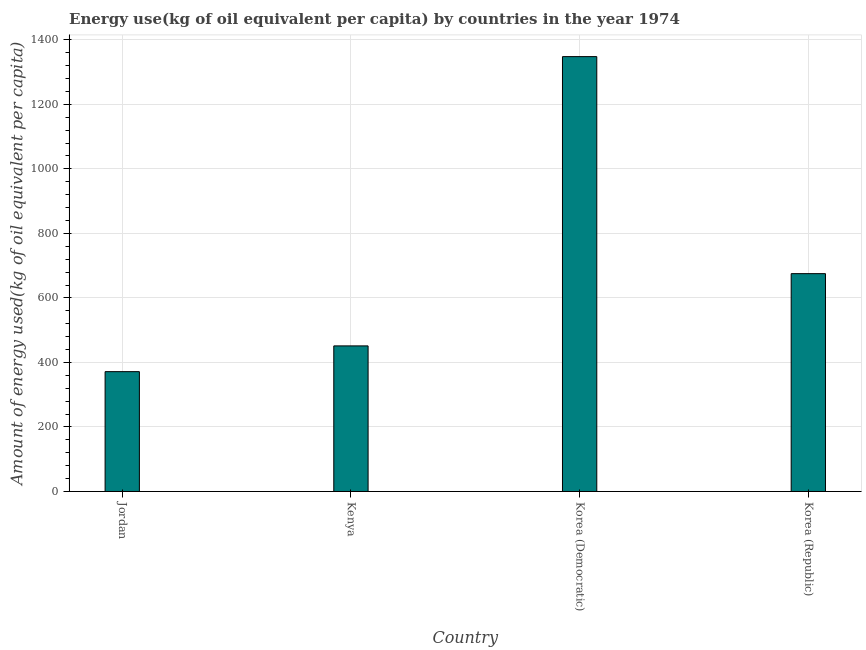Does the graph contain grids?
Offer a terse response. Yes. What is the title of the graph?
Provide a short and direct response. Energy use(kg of oil equivalent per capita) by countries in the year 1974. What is the label or title of the X-axis?
Make the answer very short. Country. What is the label or title of the Y-axis?
Your answer should be compact. Amount of energy used(kg of oil equivalent per capita). What is the amount of energy used in Korea (Democratic)?
Offer a very short reply. 1348.04. Across all countries, what is the maximum amount of energy used?
Provide a succinct answer. 1348.04. Across all countries, what is the minimum amount of energy used?
Your response must be concise. 371.48. In which country was the amount of energy used maximum?
Provide a succinct answer. Korea (Democratic). In which country was the amount of energy used minimum?
Offer a very short reply. Jordan. What is the sum of the amount of energy used?
Provide a short and direct response. 2846.09. What is the difference between the amount of energy used in Jordan and Korea (Republic)?
Your response must be concise. -303.8. What is the average amount of energy used per country?
Ensure brevity in your answer.  711.52. What is the median amount of energy used?
Ensure brevity in your answer.  563.29. In how many countries, is the amount of energy used greater than 400 kg?
Keep it short and to the point. 3. What is the ratio of the amount of energy used in Jordan to that in Korea (Republic)?
Provide a short and direct response. 0.55. What is the difference between the highest and the second highest amount of energy used?
Your response must be concise. 672.76. Is the sum of the amount of energy used in Jordan and Korea (Republic) greater than the maximum amount of energy used across all countries?
Provide a short and direct response. No. What is the difference between the highest and the lowest amount of energy used?
Ensure brevity in your answer.  976.56. What is the difference between two consecutive major ticks on the Y-axis?
Provide a succinct answer. 200. What is the Amount of energy used(kg of oil equivalent per capita) in Jordan?
Keep it short and to the point. 371.48. What is the Amount of energy used(kg of oil equivalent per capita) of Kenya?
Your response must be concise. 451.3. What is the Amount of energy used(kg of oil equivalent per capita) in Korea (Democratic)?
Provide a short and direct response. 1348.04. What is the Amount of energy used(kg of oil equivalent per capita) in Korea (Republic)?
Your answer should be very brief. 675.27. What is the difference between the Amount of energy used(kg of oil equivalent per capita) in Jordan and Kenya?
Keep it short and to the point. -79.83. What is the difference between the Amount of energy used(kg of oil equivalent per capita) in Jordan and Korea (Democratic)?
Provide a succinct answer. -976.56. What is the difference between the Amount of energy used(kg of oil equivalent per capita) in Jordan and Korea (Republic)?
Provide a short and direct response. -303.8. What is the difference between the Amount of energy used(kg of oil equivalent per capita) in Kenya and Korea (Democratic)?
Your answer should be very brief. -896.73. What is the difference between the Amount of energy used(kg of oil equivalent per capita) in Kenya and Korea (Republic)?
Give a very brief answer. -223.97. What is the difference between the Amount of energy used(kg of oil equivalent per capita) in Korea (Democratic) and Korea (Republic)?
Offer a terse response. 672.76. What is the ratio of the Amount of energy used(kg of oil equivalent per capita) in Jordan to that in Kenya?
Provide a short and direct response. 0.82. What is the ratio of the Amount of energy used(kg of oil equivalent per capita) in Jordan to that in Korea (Democratic)?
Ensure brevity in your answer.  0.28. What is the ratio of the Amount of energy used(kg of oil equivalent per capita) in Jordan to that in Korea (Republic)?
Give a very brief answer. 0.55. What is the ratio of the Amount of energy used(kg of oil equivalent per capita) in Kenya to that in Korea (Democratic)?
Offer a terse response. 0.34. What is the ratio of the Amount of energy used(kg of oil equivalent per capita) in Kenya to that in Korea (Republic)?
Offer a terse response. 0.67. What is the ratio of the Amount of energy used(kg of oil equivalent per capita) in Korea (Democratic) to that in Korea (Republic)?
Keep it short and to the point. 2. 